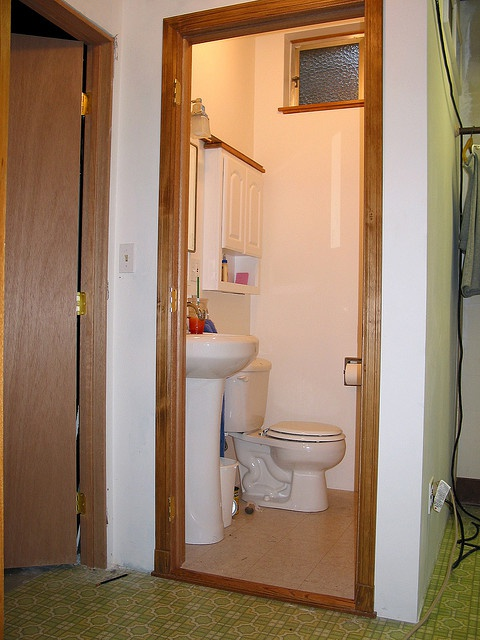Describe the objects in this image and their specific colors. I can see toilet in maroon, darkgray, tan, and gray tones, sink in maroon, darkgray, tan, and gray tones, and toothbrush in maroon, tan, and darkgreen tones in this image. 